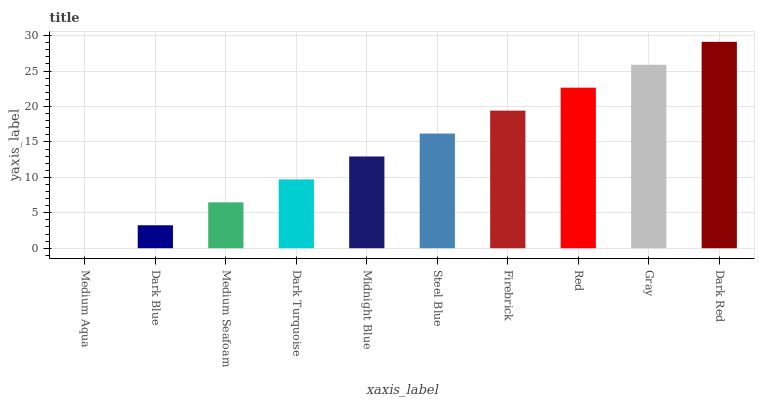Is Dark Blue the minimum?
Answer yes or no. No. Is Dark Blue the maximum?
Answer yes or no. No. Is Dark Blue greater than Medium Aqua?
Answer yes or no. Yes. Is Medium Aqua less than Dark Blue?
Answer yes or no. Yes. Is Medium Aqua greater than Dark Blue?
Answer yes or no. No. Is Dark Blue less than Medium Aqua?
Answer yes or no. No. Is Steel Blue the high median?
Answer yes or no. Yes. Is Midnight Blue the low median?
Answer yes or no. Yes. Is Firebrick the high median?
Answer yes or no. No. Is Firebrick the low median?
Answer yes or no. No. 